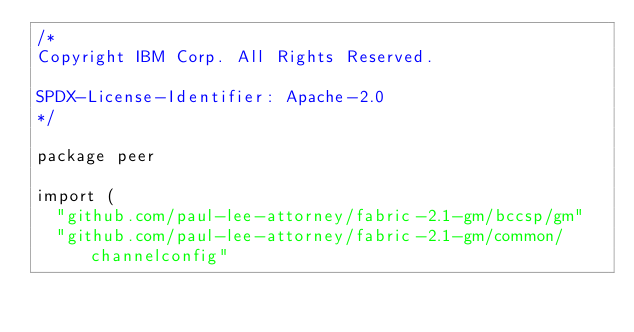<code> <loc_0><loc_0><loc_500><loc_500><_Go_>/*
Copyright IBM Corp. All Rights Reserved.

SPDX-License-Identifier: Apache-2.0
*/

package peer

import (
	"github.com/paul-lee-attorney/fabric-2.1-gm/bccsp/gm"
	"github.com/paul-lee-attorney/fabric-2.1-gm/common/channelconfig"</code> 